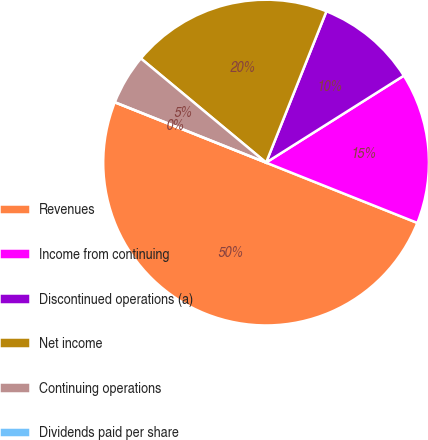Convert chart. <chart><loc_0><loc_0><loc_500><loc_500><pie_chart><fcel>Revenues<fcel>Income from continuing<fcel>Discontinued operations (a)<fcel>Net income<fcel>Continuing operations<fcel>Dividends paid per share<nl><fcel>50.0%<fcel>15.0%<fcel>10.0%<fcel>20.0%<fcel>5.0%<fcel>0.0%<nl></chart> 